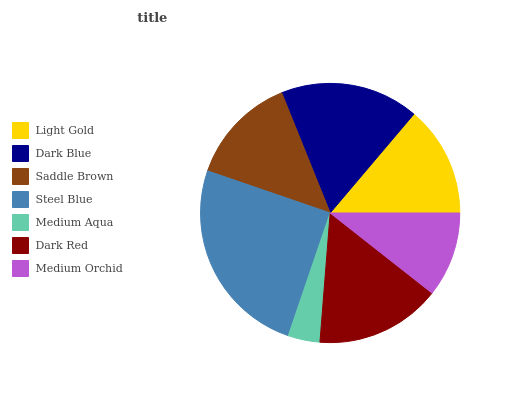Is Medium Aqua the minimum?
Answer yes or no. Yes. Is Steel Blue the maximum?
Answer yes or no. Yes. Is Dark Blue the minimum?
Answer yes or no. No. Is Dark Blue the maximum?
Answer yes or no. No. Is Dark Blue greater than Light Gold?
Answer yes or no. Yes. Is Light Gold less than Dark Blue?
Answer yes or no. Yes. Is Light Gold greater than Dark Blue?
Answer yes or no. No. Is Dark Blue less than Light Gold?
Answer yes or no. No. Is Light Gold the high median?
Answer yes or no. Yes. Is Light Gold the low median?
Answer yes or no. Yes. Is Saddle Brown the high median?
Answer yes or no. No. Is Steel Blue the low median?
Answer yes or no. No. 